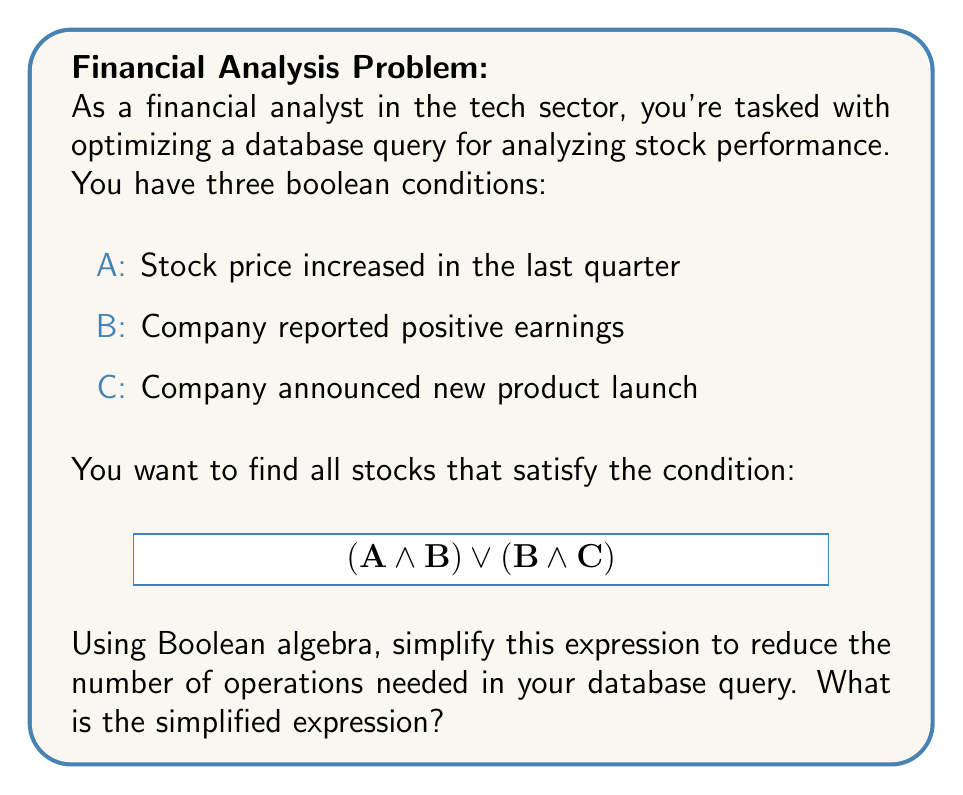Could you help me with this problem? Let's simplify the given expression (A AND B) OR (B AND C) using Boolean algebra:

1) First, let's use the distributive property of Boolean algebra:
   $$(A \land B) \lor (B \land C) = B \land (A \lor C)$$

2) This simplification is based on the following Boolean algebra rule:
   $$X \land (Y \lor Z) = (X \land Y) \lor (X \land Z)$$

3) In our case:
   X = B
   Y = A
   Z = C

4) By applying this rule in reverse, we've reduced the expression from two AND operations and one OR operation to one AND operation and one OR operation.

5) This simplification means that instead of evaluating (A AND B) and (B AND C) separately and then combining the results with OR, we can:
   - First, evaluate (A OR C)
   - Then, AND the result with B

6) This reduces the number of operations and can potentially speed up the database query, especially when dealing with large datasets common in financial analysis.
Answer: $B \land (A \lor C)$ 